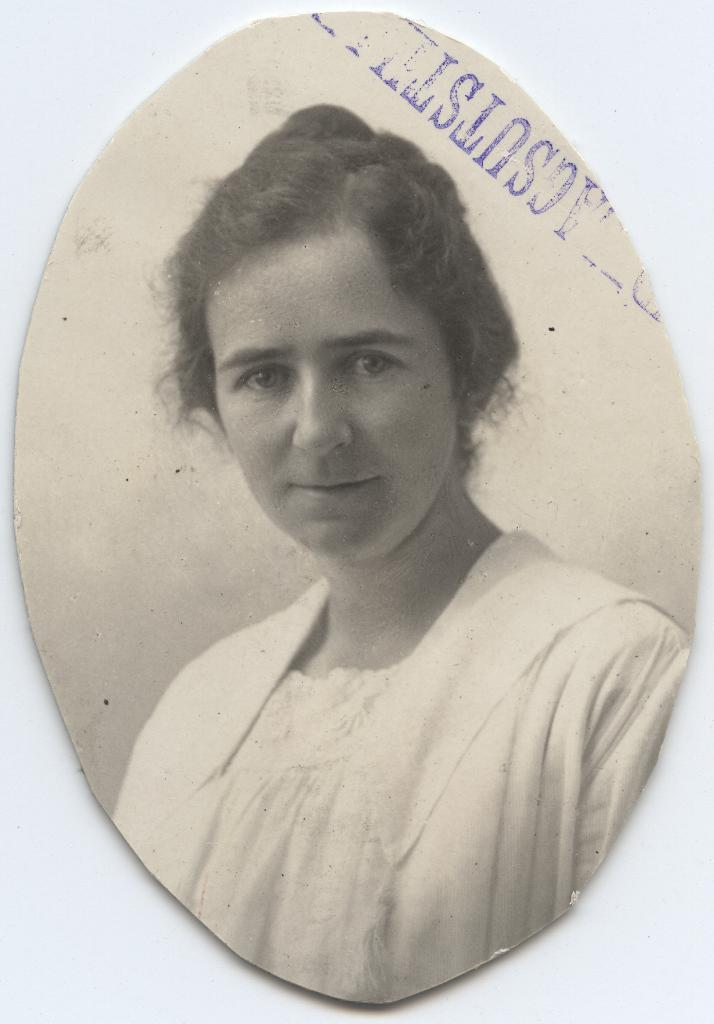What type of image is being described? The image is a portrait. Who is the main subject of the portrait? There is a woman in the picture. What color is the background of the portrait? The background of the picture is white. What type of horse can be seen in the portrait? There is no horse present in the portrait; it features a woman with a white background. How does the woman contribute to the society in the portrait? The portrait does not provide information about the woman's contribution to society; it simply depicts her as the main subject. 